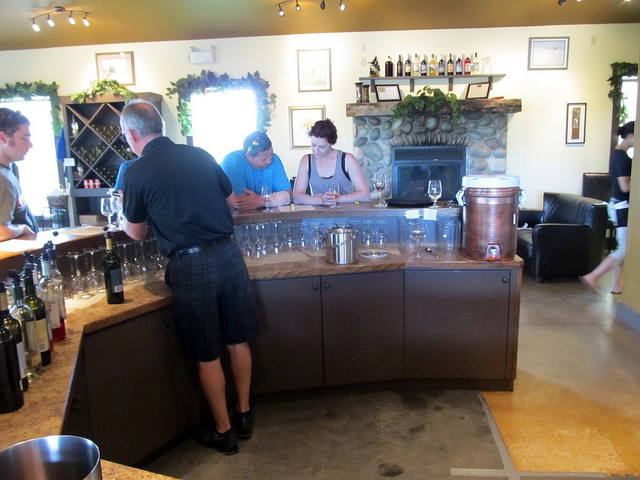Describe the objects in this image and their specific colors. I can see people in darkgray, black, navy, maroon, and darkblue tones, chair in darkgray, black, navy, gray, and darkblue tones, couch in darkgray, black, navy, gray, and darkblue tones, people in darkgray, gray, and lavender tones, and people in darkgray, gray, and lavender tones in this image. 